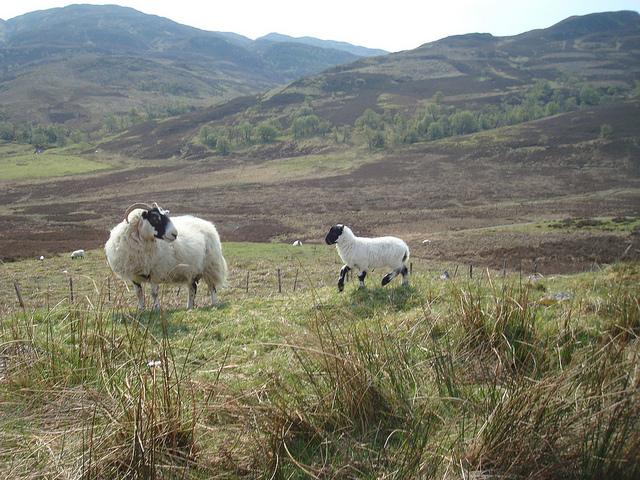Does the larger sheep have a collar?
Give a very brief answer. No. How many sheep are pictured?
Be succinct. 2. How many sheep are grazing?
Write a very short answer. 2. What is the difference between the two animals?
Quick response, please. Size. 